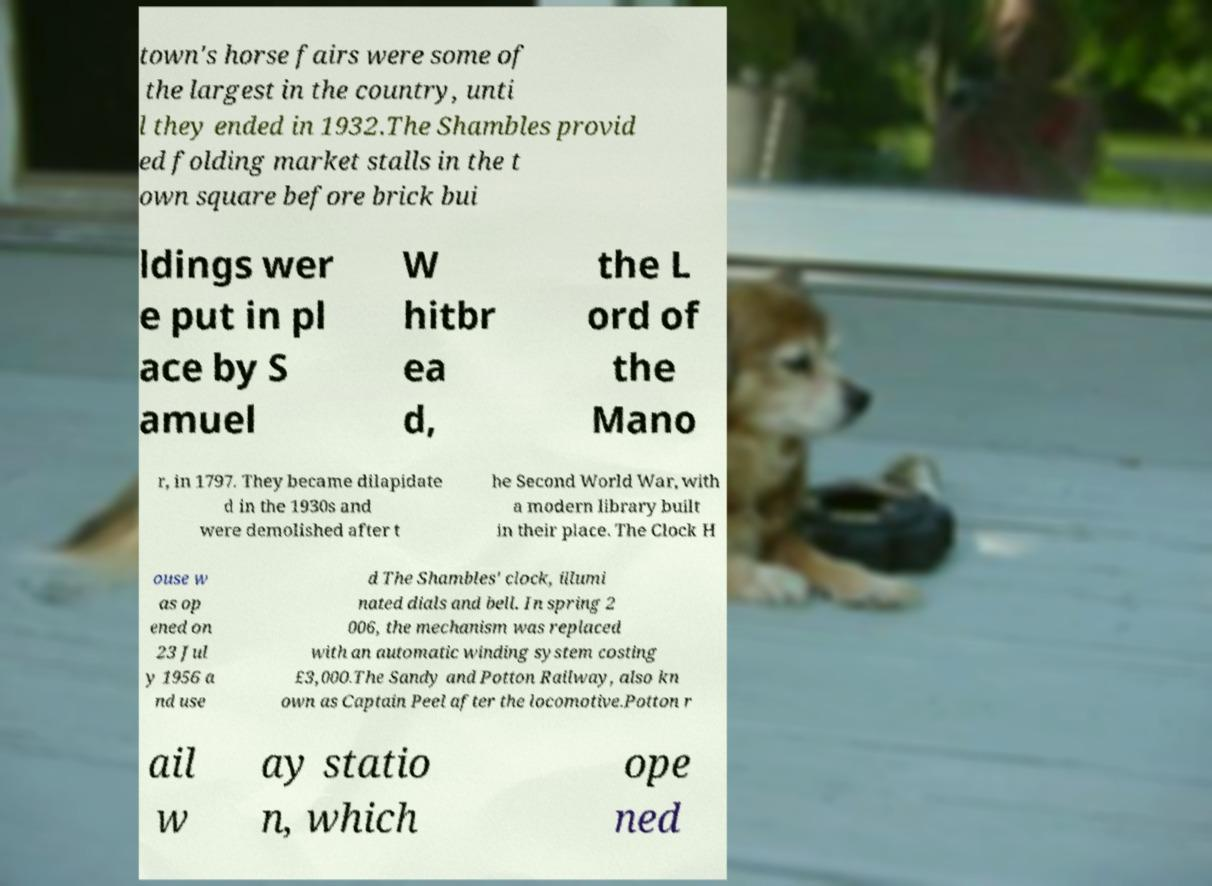There's text embedded in this image that I need extracted. Can you transcribe it verbatim? town's horse fairs were some of the largest in the country, unti l they ended in 1932.The Shambles provid ed folding market stalls in the t own square before brick bui ldings wer e put in pl ace by S amuel W hitbr ea d, the L ord of the Mano r, in 1797. They became dilapidate d in the 1930s and were demolished after t he Second World War, with a modern library built in their place. The Clock H ouse w as op ened on 23 Jul y 1956 a nd use d The Shambles' clock, illumi nated dials and bell. In spring 2 006, the mechanism was replaced with an automatic winding system costing £3,000.The Sandy and Potton Railway, also kn own as Captain Peel after the locomotive.Potton r ail w ay statio n, which ope ned 